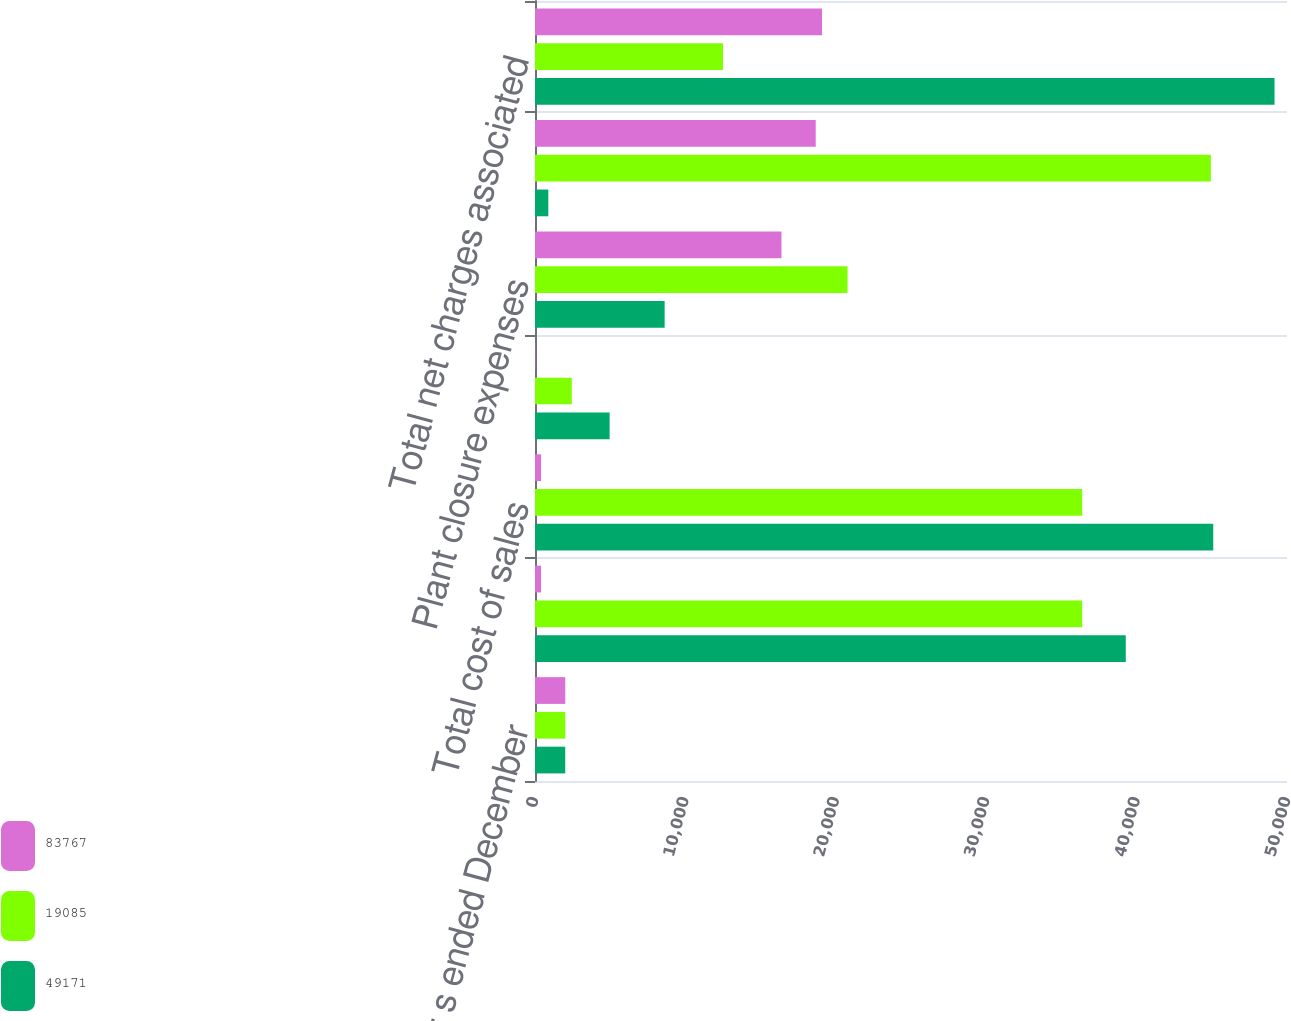Convert chart to OTSL. <chart><loc_0><loc_0><loc_500><loc_500><stacked_bar_chart><ecel><fcel>For the year s ended December<fcel>Next Century program<fcel>Total cost of sales<fcel>Selling marketing and<fcel>Plant closure expenses<fcel>Total business realignment and<fcel>Total net charges associated<nl><fcel>83767<fcel>2013<fcel>402<fcel>402<fcel>18<fcel>16387<fcel>18665<fcel>19085<nl><fcel>19085<fcel>2012<fcel>36383<fcel>36383<fcel>2446<fcel>20780<fcel>44938<fcel>12503.5<nl><fcel>49171<fcel>2011<fcel>39280<fcel>45096<fcel>4961<fcel>8620<fcel>886<fcel>49171<nl></chart> 